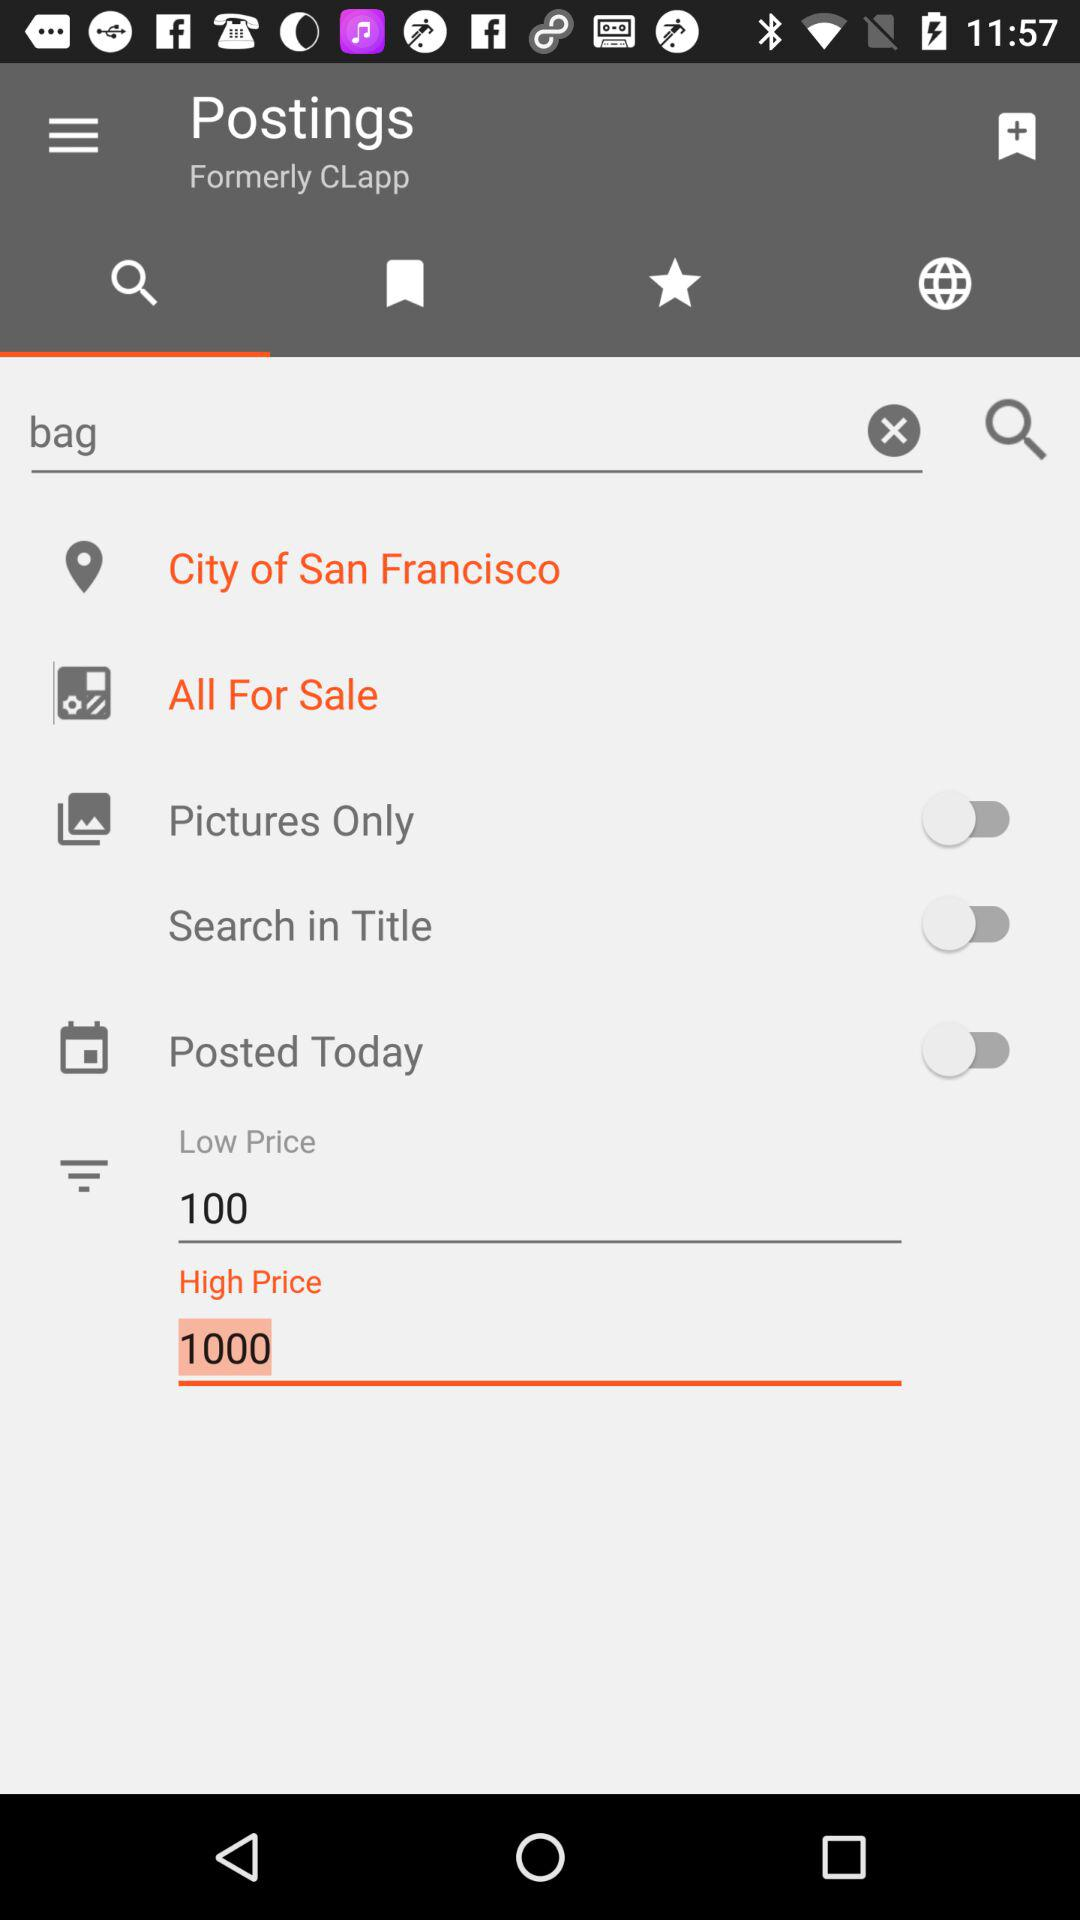What is the status of the "Search in Title"? The status is "off". 